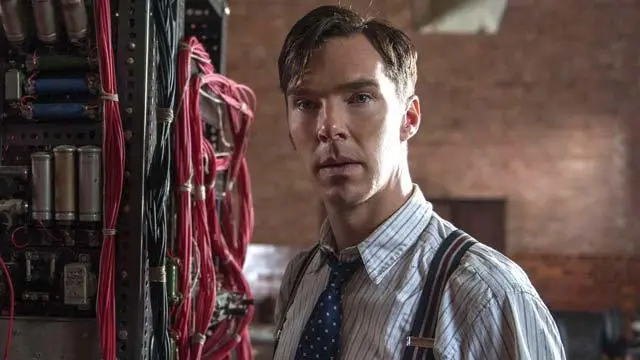What are the key elements in this picture? The image features a man dressed in period-appropriate attire consisting of a crisp white shirt, a patterned tie, and striped suspenders, suggesting a historical setting. He is standing by a complex mechanical setup filled with wires and cylinders, indicating technological or scientific activity. His serious expression and sideways gaze contribute to an atmosphere of deep thought or concern, aligning with the narrative of a professional deeply engaged in critical work. This portrayal points to a scene set in a past era, reflective of significant historical or biographical narratives. 